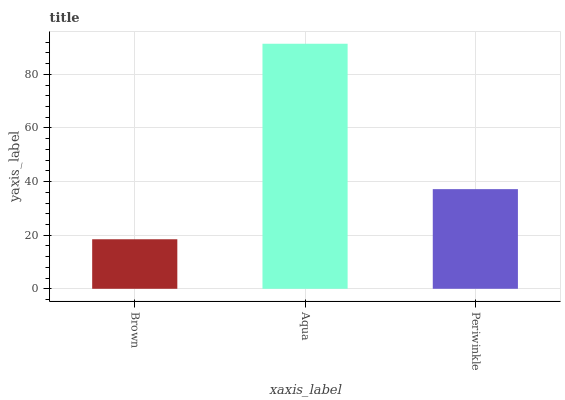Is Brown the minimum?
Answer yes or no. Yes. Is Aqua the maximum?
Answer yes or no. Yes. Is Periwinkle the minimum?
Answer yes or no. No. Is Periwinkle the maximum?
Answer yes or no. No. Is Aqua greater than Periwinkle?
Answer yes or no. Yes. Is Periwinkle less than Aqua?
Answer yes or no. Yes. Is Periwinkle greater than Aqua?
Answer yes or no. No. Is Aqua less than Periwinkle?
Answer yes or no. No. Is Periwinkle the high median?
Answer yes or no. Yes. Is Periwinkle the low median?
Answer yes or no. Yes. Is Aqua the high median?
Answer yes or no. No. Is Brown the low median?
Answer yes or no. No. 